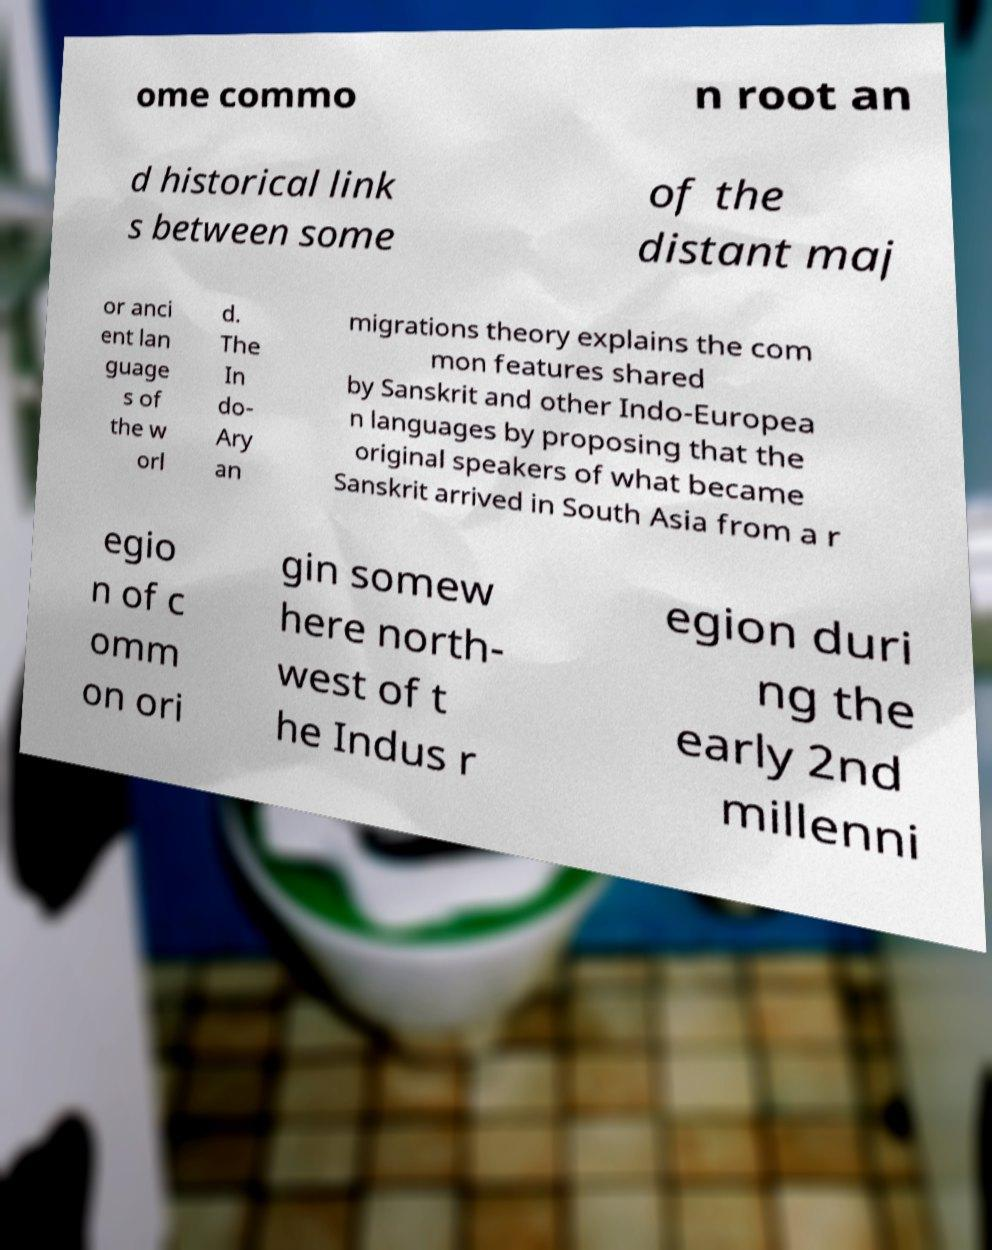There's text embedded in this image that I need extracted. Can you transcribe it verbatim? ome commo n root an d historical link s between some of the distant maj or anci ent lan guage s of the w orl d. The In do- Ary an migrations theory explains the com mon features shared by Sanskrit and other Indo-Europea n languages by proposing that the original speakers of what became Sanskrit arrived in South Asia from a r egio n of c omm on ori gin somew here north- west of t he Indus r egion duri ng the early 2nd millenni 